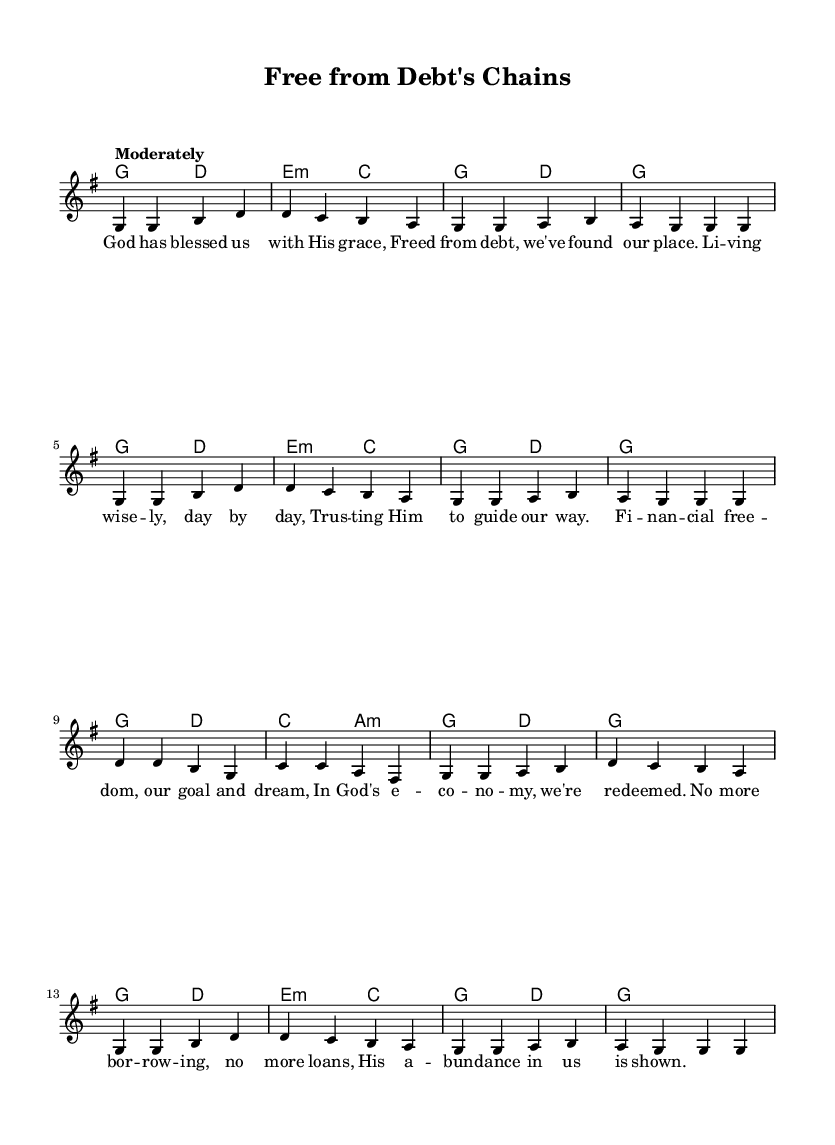What is the key signature of this music? The key signature is indicated at the beginning of the score following the word "key," which shows there is one sharp on the F line. This key signature corresponds to G major.
Answer: G major What is the time signature of this music? The time signature is found in the section labeled "time," where it states "4/4." This means there are four beats in a measure, and the quarter note gets one beat.
Answer: 4/4 What is the tempo marking of this music? The tempo marking is specified after the "tempo" label at the beginning of the score, which instructs musicians to play the piece moderately.
Answer: Moderately How many measures are in the chorus? By counting the number of bar lines separating the notes in the chorus section, there are a total of 8 measures.
Answer: 8 What is the main theme of the lyrics? The lyrics describe the concept of financial freedom and trusting in God to live debt-free, prominently mentioning the avoidance of borrowing and loans.
Answer: Financial freedom Which chord appears at the start of the melody? The first chord seen at the beginning of the melody is indicated in the harmony section, where it shows a G major chord.
Answer: G major 